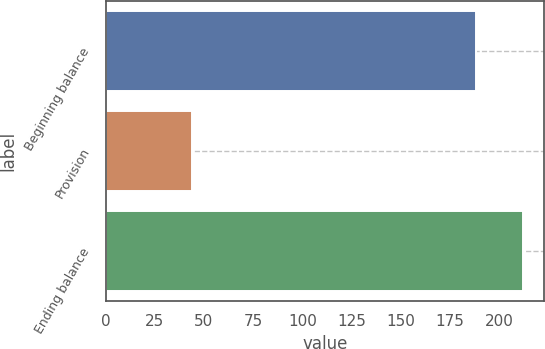Convert chart. <chart><loc_0><loc_0><loc_500><loc_500><bar_chart><fcel>Beginning balance<fcel>Provision<fcel>Ending balance<nl><fcel>188<fcel>44<fcel>212<nl></chart> 